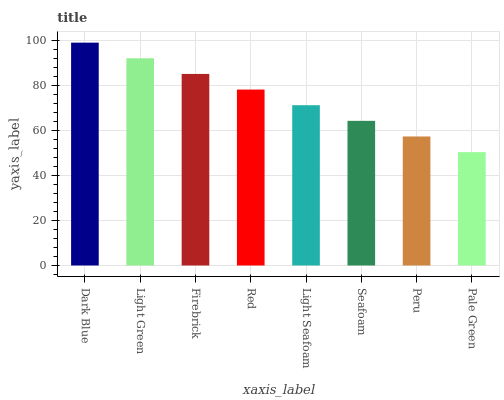Is Pale Green the minimum?
Answer yes or no. Yes. Is Dark Blue the maximum?
Answer yes or no. Yes. Is Light Green the minimum?
Answer yes or no. No. Is Light Green the maximum?
Answer yes or no. No. Is Dark Blue greater than Light Green?
Answer yes or no. Yes. Is Light Green less than Dark Blue?
Answer yes or no. Yes. Is Light Green greater than Dark Blue?
Answer yes or no. No. Is Dark Blue less than Light Green?
Answer yes or no. No. Is Red the high median?
Answer yes or no. Yes. Is Light Seafoam the low median?
Answer yes or no. Yes. Is Firebrick the high median?
Answer yes or no. No. Is Dark Blue the low median?
Answer yes or no. No. 